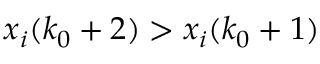<formula> <loc_0><loc_0><loc_500><loc_500>x _ { i } ( k _ { 0 } + 2 ) > x _ { i } ( k _ { 0 } + 1 )</formula> 